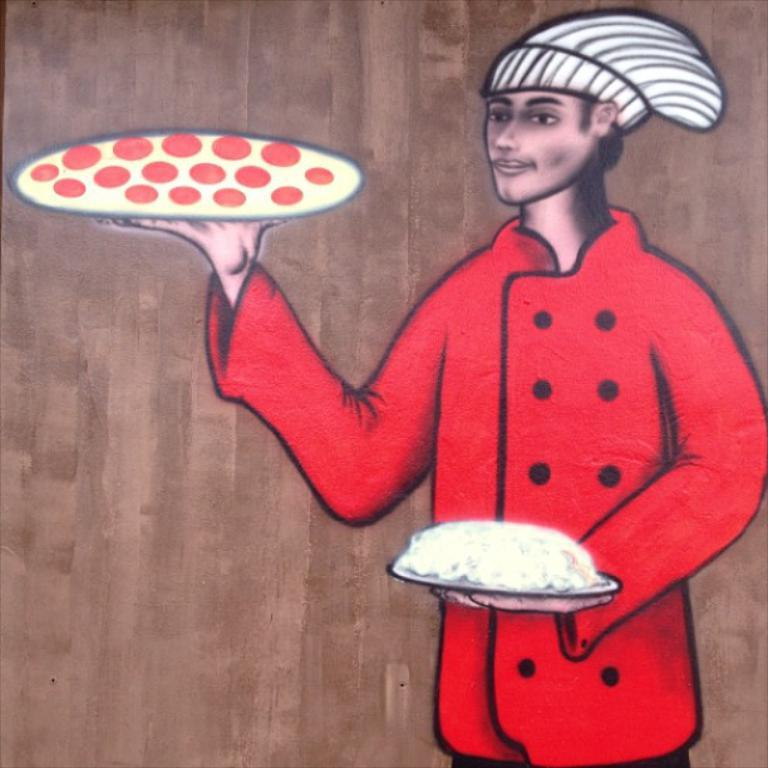What is the main subject of the image? The image contains a painting. What is the color of the surface on which the painting is displayed? The painting is on a brown color surface. What is depicted in the painting? The painting depicts a person. What is the person in the painting wearing? The person in the painting is wearing a red dress. What is the person in the painting holding? The person in the painting is holding plates with food. What type of pan can be seen in the painting? There is no pan present in the painting; it depicts a person holding plates with food. Who is the painting representative of? The painting is not a representation of a specific person; it is a work of art depicting a person wearing a red dress and holding plates with food. 